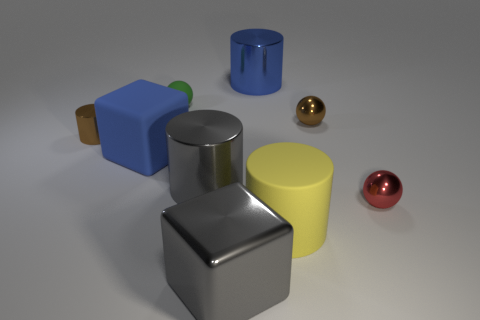Subtract all blue cylinders. How many cylinders are left? 3 Add 1 big green balls. How many objects exist? 10 Subtract all green spheres. How many spheres are left? 2 Subtract 1 blocks. How many blocks are left? 1 Subtract all blocks. How many objects are left? 7 Subtract all yellow cylinders. Subtract all red balls. How many cylinders are left? 3 Subtract all blue balls. How many yellow cylinders are left? 1 Subtract all yellow objects. Subtract all tiny cyan matte blocks. How many objects are left? 8 Add 9 blue cylinders. How many blue cylinders are left? 10 Add 1 tiny balls. How many tiny balls exist? 4 